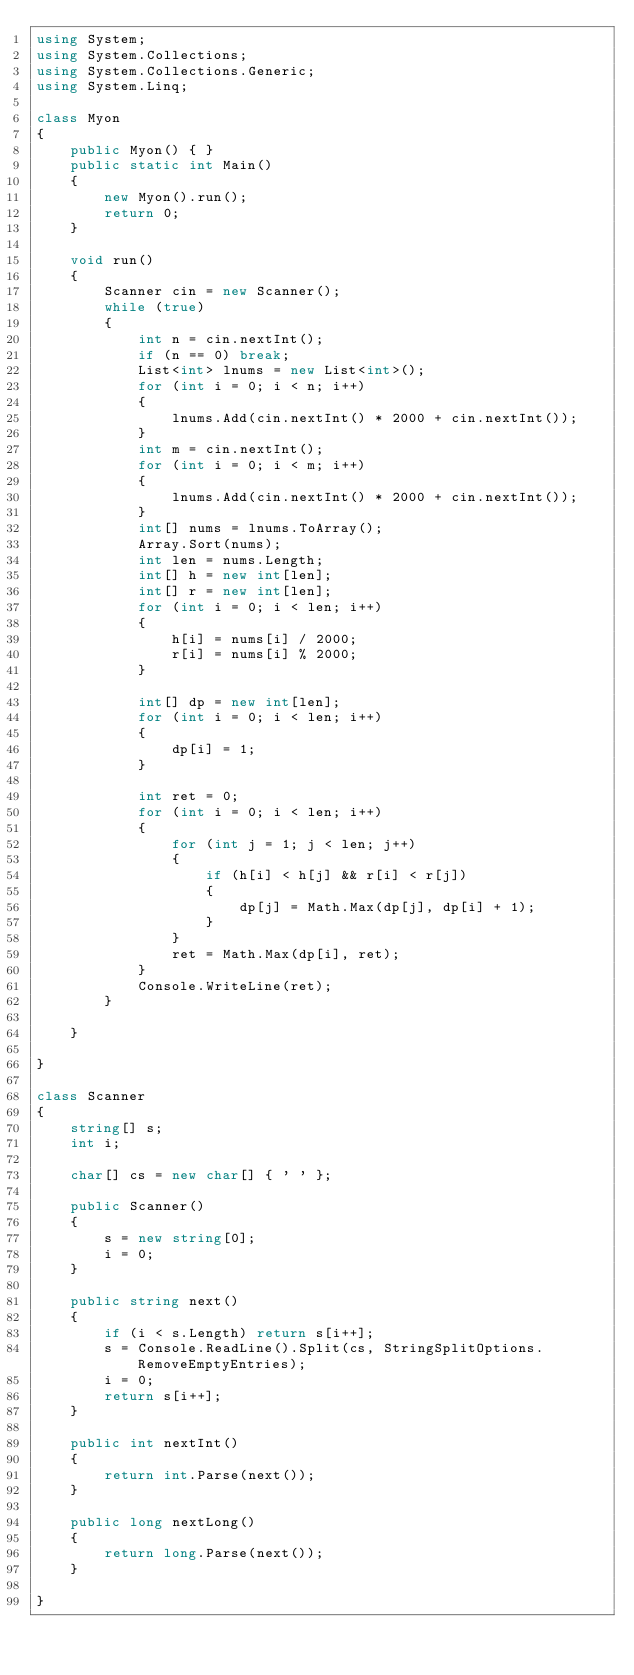<code> <loc_0><loc_0><loc_500><loc_500><_C#_>using System;
using System.Collections;
using System.Collections.Generic;
using System.Linq;

class Myon
{
    public Myon() { }
    public static int Main()
    {
        new Myon().run();
        return 0;
    }

    void run()
    {
        Scanner cin = new Scanner();
        while (true)
        {
            int n = cin.nextInt();
            if (n == 0) break;
            List<int> lnums = new List<int>();
            for (int i = 0; i < n; i++)
            {
                lnums.Add(cin.nextInt() * 2000 + cin.nextInt());
            }
            int m = cin.nextInt();
            for (int i = 0; i < m; i++)
            {
                lnums.Add(cin.nextInt() * 2000 + cin.nextInt());
            }
            int[] nums = lnums.ToArray();
            Array.Sort(nums);
            int len = nums.Length;
            int[] h = new int[len];
            int[] r = new int[len];
            for (int i = 0; i < len; i++)
            {
                h[i] = nums[i] / 2000;
                r[i] = nums[i] % 2000;
            }

            int[] dp = new int[len];
            for (int i = 0; i < len; i++)
            {
                dp[i] = 1;
            }

            int ret = 0;
            for (int i = 0; i < len; i++)
            {
                for (int j = 1; j < len; j++)
                {
                    if (h[i] < h[j] && r[i] < r[j])
                    {
                        dp[j] = Math.Max(dp[j], dp[i] + 1);
                    }
                }
                ret = Math.Max(dp[i], ret);
            }
            Console.WriteLine(ret);
        }

    }

}

class Scanner
{
    string[] s;
    int i;

    char[] cs = new char[] { ' ' };

    public Scanner()
    {
        s = new string[0];
        i = 0;
    }

    public string next()
    {
        if (i < s.Length) return s[i++];
        s = Console.ReadLine().Split(cs, StringSplitOptions.RemoveEmptyEntries);
        i = 0;
        return s[i++];
    }

    public int nextInt()
    {
        return int.Parse(next());
    }

    public long nextLong()
    {
        return long.Parse(next());
    }

}</code> 